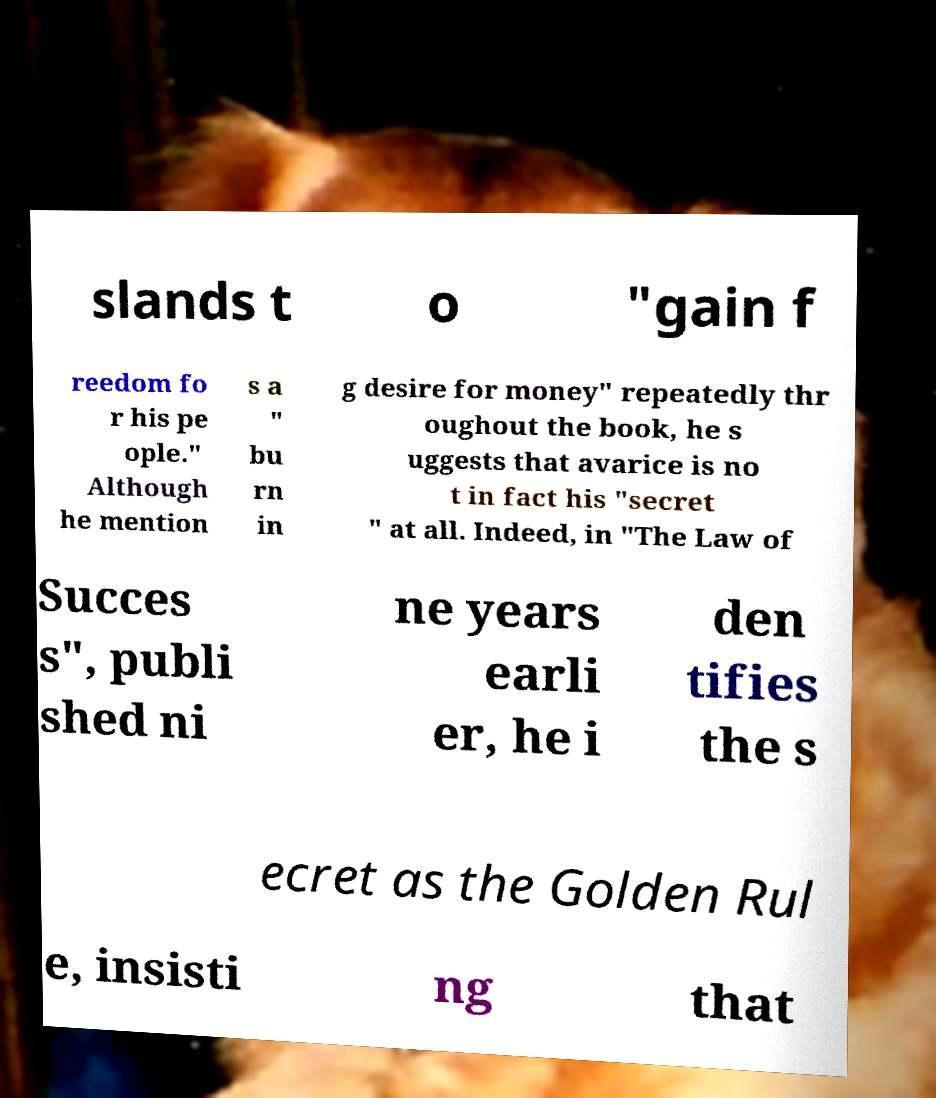Please read and relay the text visible in this image. What does it say? slands t o "gain f reedom fo r his pe ople." Although he mention s a " bu rn in g desire for money" repeatedly thr oughout the book, he s uggests that avarice is no t in fact his "secret " at all. Indeed, in "The Law of Succes s", publi shed ni ne years earli er, he i den tifies the s ecret as the Golden Rul e, insisti ng that 